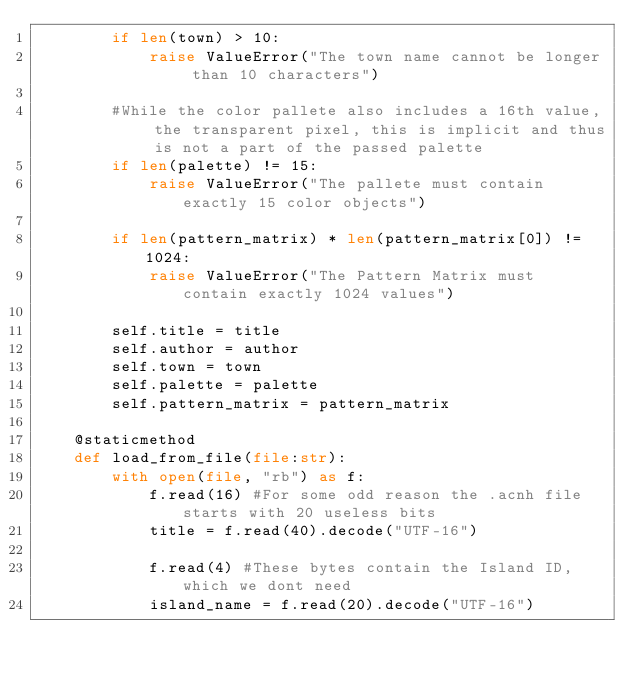Convert code to text. <code><loc_0><loc_0><loc_500><loc_500><_Python_>        if len(town) > 10:
            raise ValueError("The town name cannot be longer than 10 characters")
         
        #While the color pallete also includes a 16th value, the transparent pixel, this is implicit and thus is not a part of the passed palette
        if len(palette) != 15:
            raise ValueError("The pallete must contain exactly 15 color objects")
        
        if len(pattern_matrix) * len(pattern_matrix[0]) != 1024:
            raise ValueError("The Pattern Matrix must contain exactly 1024 values")
        
        self.title = title
        self.author = author
        self.town = town
        self.palette = palette
        self.pattern_matrix = pattern_matrix
    
    @staticmethod
    def load_from_file(file:str):
        with open(file, "rb") as f:
            f.read(16) #For some odd reason the .acnh file starts with 20 useless bits
            title = f.read(40).decode("UTF-16")

            f.read(4) #These bytes contain the Island ID, which we dont need
            island_name = f.read(20).decode("UTF-16")</code> 